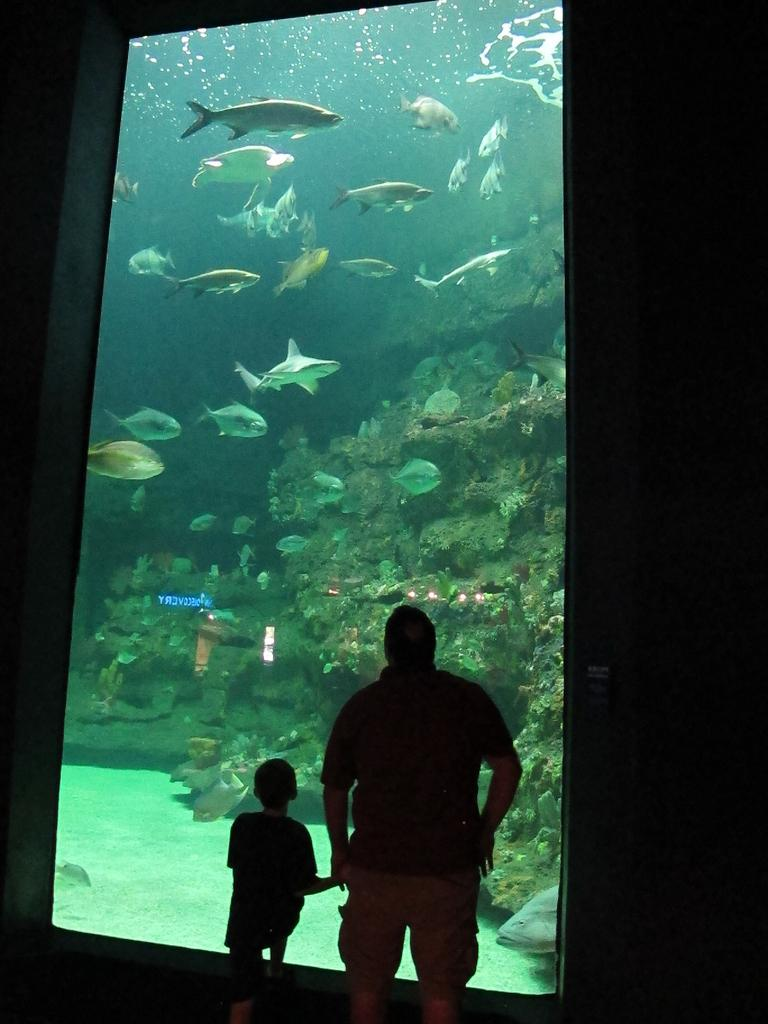How many people are in the image? There are two persons in the image. What are the persons doing in the image? The persons are standing in front of an aquarium. What can be seen inside the aquarium? The aquarium contains fishes. What type of bead is being used to surprise the fish in the image? There is no bead or surprise element present in the image; it features two persons standing in front of an aquarium with fishes. Can you see a receipt for the fish in the image? There is no receipt visible in the image; it only shows two persons standing in front of an aquarium with fishes. 